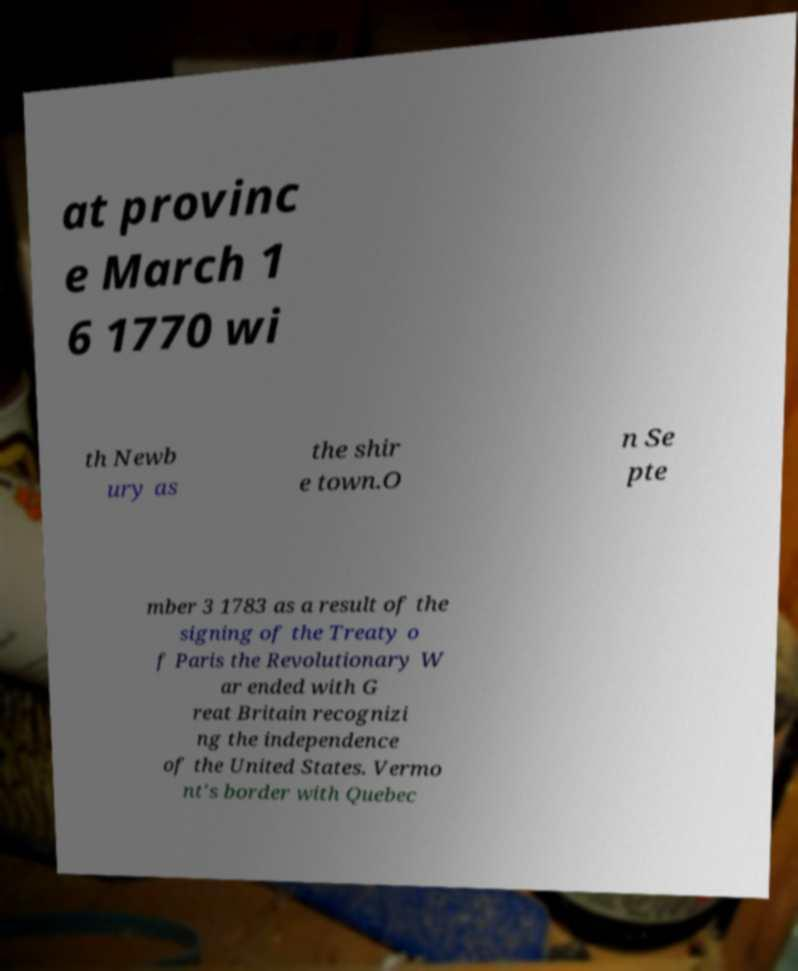Please identify and transcribe the text found in this image. at provinc e March 1 6 1770 wi th Newb ury as the shir e town.O n Se pte mber 3 1783 as a result of the signing of the Treaty o f Paris the Revolutionary W ar ended with G reat Britain recognizi ng the independence of the United States. Vermo nt's border with Quebec 